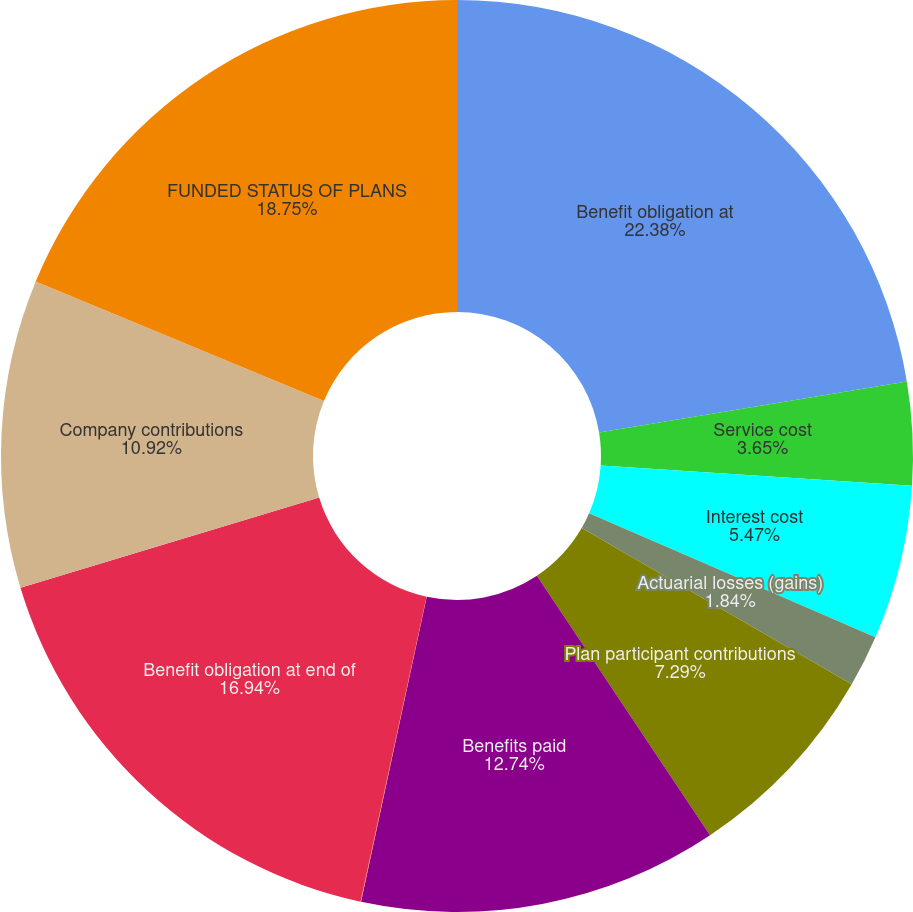Convert chart to OTSL. <chart><loc_0><loc_0><loc_500><loc_500><pie_chart><fcel>Benefit obligation at<fcel>Service cost<fcel>Interest cost<fcel>Actuarial losses (gains)<fcel>Plan participant contributions<fcel>Benefits paid<fcel>Currency translation and other<fcel>Benefit obligation at end of<fcel>Company contributions<fcel>FUNDED STATUS OF PLANS<nl><fcel>22.39%<fcel>3.65%<fcel>5.47%<fcel>1.84%<fcel>7.29%<fcel>12.74%<fcel>0.02%<fcel>16.94%<fcel>10.92%<fcel>18.75%<nl></chart> 